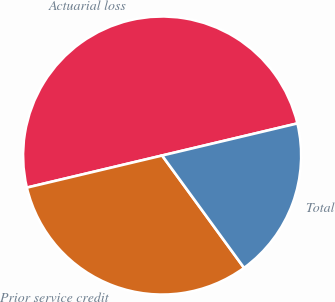<chart> <loc_0><loc_0><loc_500><loc_500><pie_chart><fcel>Actuarial loss<fcel>Prior service credit<fcel>Total<nl><fcel>50.0%<fcel>31.32%<fcel>18.68%<nl></chart> 